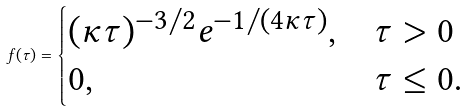<formula> <loc_0><loc_0><loc_500><loc_500>f ( \tau ) = \begin{cases} ( \kappa \tau ) ^ { - 3 / 2 } e ^ { - 1 / ( 4 { \kappa \tau } ) } , & \tau > 0 \\ 0 , & \tau \leq 0 . \end{cases}</formula> 